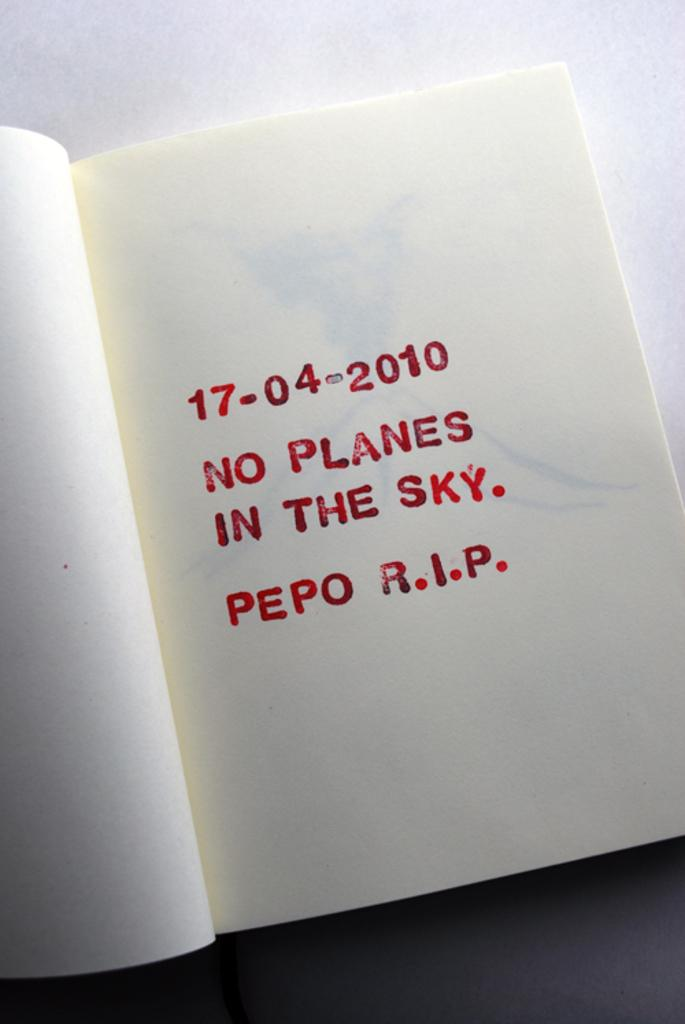<image>
Describe the image concisely. A page in a book says on 17-04-2010 there were no planes in the sky. 